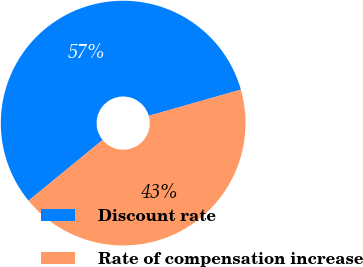Convert chart to OTSL. <chart><loc_0><loc_0><loc_500><loc_500><pie_chart><fcel>Discount rate<fcel>Rate of compensation increase<nl><fcel>56.52%<fcel>43.48%<nl></chart> 